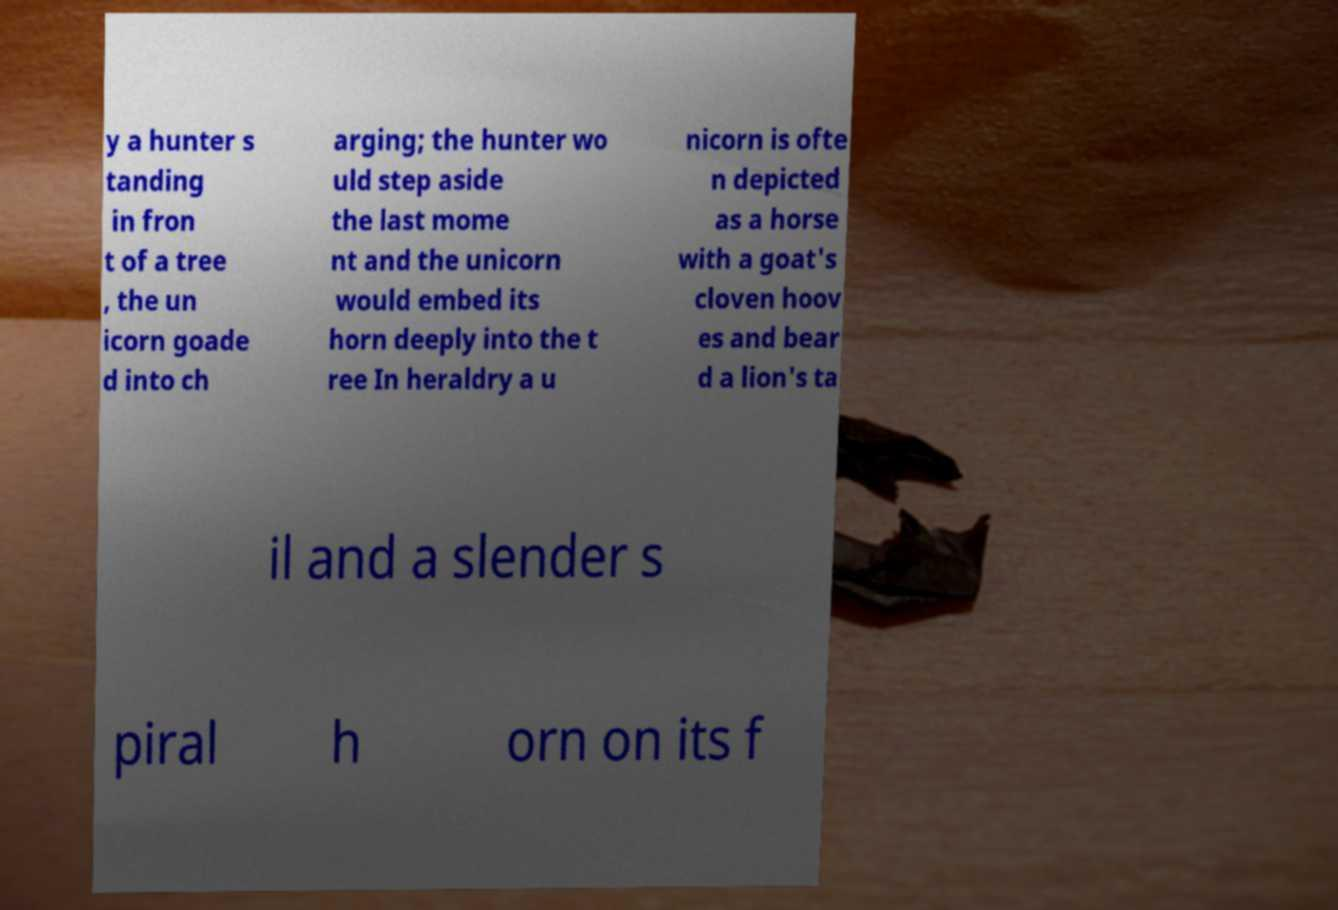Can you accurately transcribe the text from the provided image for me? y a hunter s tanding in fron t of a tree , the un icorn goade d into ch arging; the hunter wo uld step aside the last mome nt and the unicorn would embed its horn deeply into the t ree In heraldry a u nicorn is ofte n depicted as a horse with a goat's cloven hoov es and bear d a lion's ta il and a slender s piral h orn on its f 